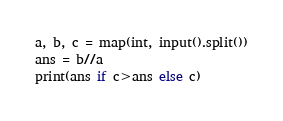Convert code to text. <code><loc_0><loc_0><loc_500><loc_500><_Python_>a, b, c = map(int, input().split())
ans = b//a
print(ans if c>ans else c)</code> 